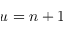Convert formula to latex. <formula><loc_0><loc_0><loc_500><loc_500>u = n \pm 1</formula> 